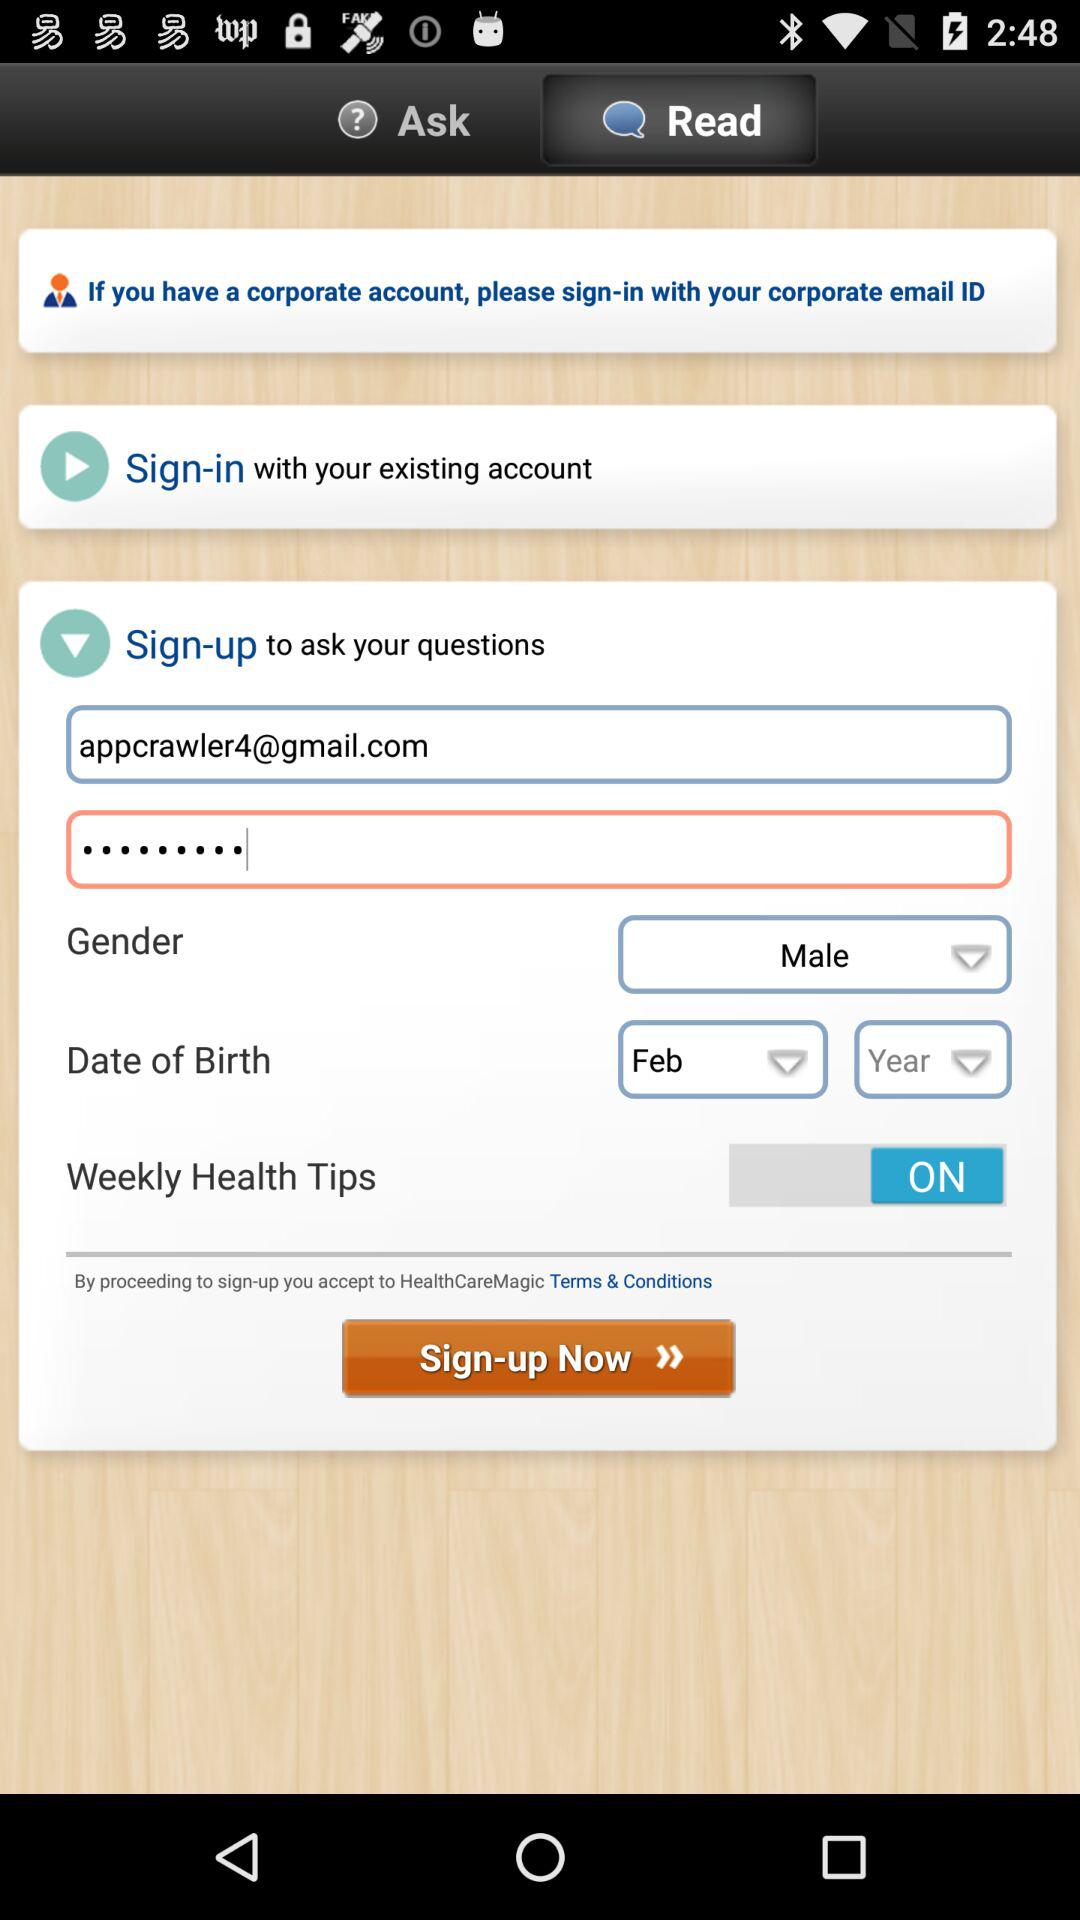Which month has been selected for the date of birth? The month that has been selected for the date of birth is February. 